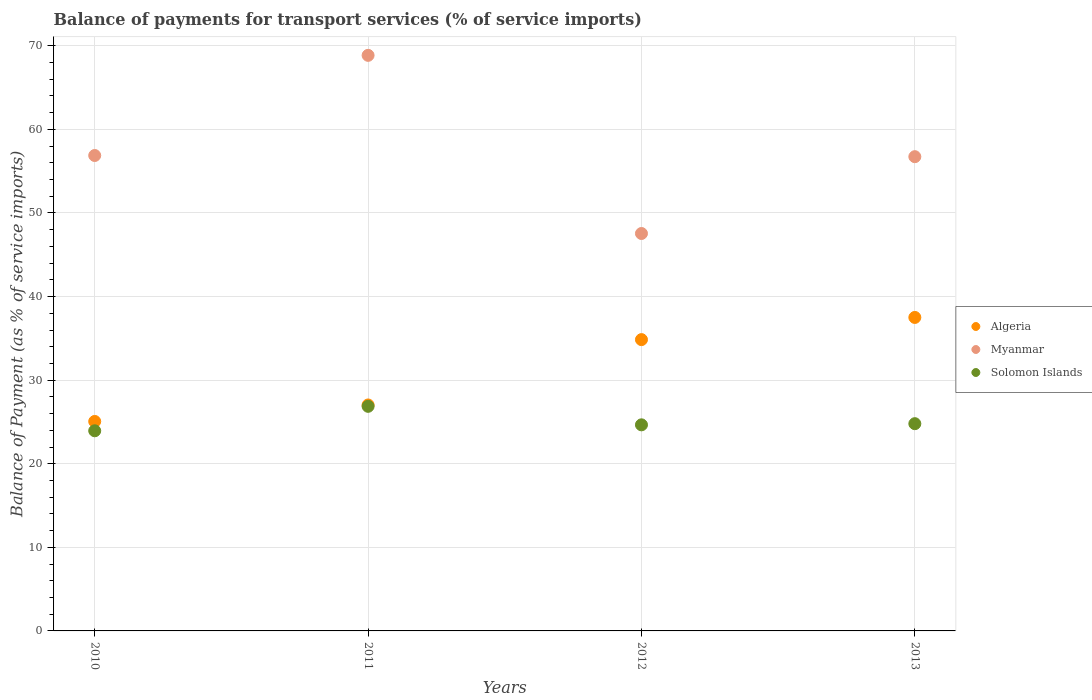How many different coloured dotlines are there?
Your answer should be compact. 3. Is the number of dotlines equal to the number of legend labels?
Make the answer very short. Yes. What is the balance of payments for transport services in Solomon Islands in 2011?
Keep it short and to the point. 26.87. Across all years, what is the maximum balance of payments for transport services in Algeria?
Your answer should be very brief. 37.5. Across all years, what is the minimum balance of payments for transport services in Solomon Islands?
Your answer should be compact. 23.94. In which year was the balance of payments for transport services in Algeria minimum?
Make the answer very short. 2010. What is the total balance of payments for transport services in Myanmar in the graph?
Offer a terse response. 230.02. What is the difference between the balance of payments for transport services in Myanmar in 2010 and that in 2013?
Give a very brief answer. 0.14. What is the difference between the balance of payments for transport services in Myanmar in 2011 and the balance of payments for transport services in Algeria in 2010?
Your answer should be very brief. 43.8. What is the average balance of payments for transport services in Solomon Islands per year?
Your answer should be compact. 25.07. In the year 2011, what is the difference between the balance of payments for transport services in Myanmar and balance of payments for transport services in Algeria?
Your answer should be compact. 41.83. In how many years, is the balance of payments for transport services in Solomon Islands greater than 38 %?
Give a very brief answer. 0. What is the ratio of the balance of payments for transport services in Myanmar in 2010 to that in 2011?
Offer a very short reply. 0.83. Is the difference between the balance of payments for transport services in Myanmar in 2012 and 2013 greater than the difference between the balance of payments for transport services in Algeria in 2012 and 2013?
Provide a short and direct response. No. What is the difference between the highest and the second highest balance of payments for transport services in Solomon Islands?
Provide a succinct answer. 2.08. What is the difference between the highest and the lowest balance of payments for transport services in Myanmar?
Make the answer very short. 21.31. Does the balance of payments for transport services in Solomon Islands monotonically increase over the years?
Your answer should be very brief. No. What is the difference between two consecutive major ticks on the Y-axis?
Give a very brief answer. 10. Does the graph contain grids?
Give a very brief answer. Yes. Where does the legend appear in the graph?
Provide a short and direct response. Center right. How many legend labels are there?
Give a very brief answer. 3. How are the legend labels stacked?
Give a very brief answer. Vertical. What is the title of the graph?
Your response must be concise. Balance of payments for transport services (% of service imports). Does "Samoa" appear as one of the legend labels in the graph?
Provide a short and direct response. No. What is the label or title of the X-axis?
Give a very brief answer. Years. What is the label or title of the Y-axis?
Offer a terse response. Balance of Payment (as % of service imports). What is the Balance of Payment (as % of service imports) of Algeria in 2010?
Provide a short and direct response. 25.06. What is the Balance of Payment (as % of service imports) in Myanmar in 2010?
Provide a short and direct response. 56.88. What is the Balance of Payment (as % of service imports) of Solomon Islands in 2010?
Provide a short and direct response. 23.94. What is the Balance of Payment (as % of service imports) of Algeria in 2011?
Your answer should be compact. 27.03. What is the Balance of Payment (as % of service imports) of Myanmar in 2011?
Offer a very short reply. 68.86. What is the Balance of Payment (as % of service imports) in Solomon Islands in 2011?
Give a very brief answer. 26.87. What is the Balance of Payment (as % of service imports) of Algeria in 2012?
Your answer should be compact. 34.85. What is the Balance of Payment (as % of service imports) in Myanmar in 2012?
Offer a terse response. 47.55. What is the Balance of Payment (as % of service imports) of Solomon Islands in 2012?
Offer a very short reply. 24.66. What is the Balance of Payment (as % of service imports) in Algeria in 2013?
Your answer should be very brief. 37.5. What is the Balance of Payment (as % of service imports) of Myanmar in 2013?
Your answer should be compact. 56.74. What is the Balance of Payment (as % of service imports) of Solomon Islands in 2013?
Offer a very short reply. 24.79. Across all years, what is the maximum Balance of Payment (as % of service imports) in Algeria?
Ensure brevity in your answer.  37.5. Across all years, what is the maximum Balance of Payment (as % of service imports) in Myanmar?
Ensure brevity in your answer.  68.86. Across all years, what is the maximum Balance of Payment (as % of service imports) of Solomon Islands?
Make the answer very short. 26.87. Across all years, what is the minimum Balance of Payment (as % of service imports) of Algeria?
Your answer should be very brief. 25.06. Across all years, what is the minimum Balance of Payment (as % of service imports) of Myanmar?
Provide a succinct answer. 47.55. Across all years, what is the minimum Balance of Payment (as % of service imports) in Solomon Islands?
Provide a short and direct response. 23.94. What is the total Balance of Payment (as % of service imports) of Algeria in the graph?
Your answer should be very brief. 124.45. What is the total Balance of Payment (as % of service imports) of Myanmar in the graph?
Your answer should be very brief. 230.02. What is the total Balance of Payment (as % of service imports) in Solomon Islands in the graph?
Make the answer very short. 100.26. What is the difference between the Balance of Payment (as % of service imports) in Algeria in 2010 and that in 2011?
Your answer should be very brief. -1.97. What is the difference between the Balance of Payment (as % of service imports) of Myanmar in 2010 and that in 2011?
Your response must be concise. -11.98. What is the difference between the Balance of Payment (as % of service imports) of Solomon Islands in 2010 and that in 2011?
Offer a very short reply. -2.93. What is the difference between the Balance of Payment (as % of service imports) of Algeria in 2010 and that in 2012?
Keep it short and to the point. -9.79. What is the difference between the Balance of Payment (as % of service imports) in Myanmar in 2010 and that in 2012?
Give a very brief answer. 9.33. What is the difference between the Balance of Payment (as % of service imports) in Solomon Islands in 2010 and that in 2012?
Keep it short and to the point. -0.71. What is the difference between the Balance of Payment (as % of service imports) of Algeria in 2010 and that in 2013?
Make the answer very short. -12.44. What is the difference between the Balance of Payment (as % of service imports) of Myanmar in 2010 and that in 2013?
Give a very brief answer. 0.14. What is the difference between the Balance of Payment (as % of service imports) in Solomon Islands in 2010 and that in 2013?
Provide a succinct answer. -0.85. What is the difference between the Balance of Payment (as % of service imports) of Algeria in 2011 and that in 2012?
Provide a short and direct response. -7.82. What is the difference between the Balance of Payment (as % of service imports) in Myanmar in 2011 and that in 2012?
Offer a terse response. 21.31. What is the difference between the Balance of Payment (as % of service imports) of Solomon Islands in 2011 and that in 2012?
Offer a very short reply. 2.21. What is the difference between the Balance of Payment (as % of service imports) in Algeria in 2011 and that in 2013?
Provide a short and direct response. -10.47. What is the difference between the Balance of Payment (as % of service imports) in Myanmar in 2011 and that in 2013?
Your answer should be compact. 12.12. What is the difference between the Balance of Payment (as % of service imports) of Solomon Islands in 2011 and that in 2013?
Offer a very short reply. 2.08. What is the difference between the Balance of Payment (as % of service imports) of Algeria in 2012 and that in 2013?
Give a very brief answer. -2.65. What is the difference between the Balance of Payment (as % of service imports) of Myanmar in 2012 and that in 2013?
Your answer should be compact. -9.19. What is the difference between the Balance of Payment (as % of service imports) in Solomon Islands in 2012 and that in 2013?
Your response must be concise. -0.14. What is the difference between the Balance of Payment (as % of service imports) in Algeria in 2010 and the Balance of Payment (as % of service imports) in Myanmar in 2011?
Your response must be concise. -43.8. What is the difference between the Balance of Payment (as % of service imports) in Algeria in 2010 and the Balance of Payment (as % of service imports) in Solomon Islands in 2011?
Provide a short and direct response. -1.81. What is the difference between the Balance of Payment (as % of service imports) of Myanmar in 2010 and the Balance of Payment (as % of service imports) of Solomon Islands in 2011?
Your response must be concise. 30.01. What is the difference between the Balance of Payment (as % of service imports) of Algeria in 2010 and the Balance of Payment (as % of service imports) of Myanmar in 2012?
Offer a terse response. -22.48. What is the difference between the Balance of Payment (as % of service imports) in Algeria in 2010 and the Balance of Payment (as % of service imports) in Solomon Islands in 2012?
Offer a very short reply. 0.41. What is the difference between the Balance of Payment (as % of service imports) of Myanmar in 2010 and the Balance of Payment (as % of service imports) of Solomon Islands in 2012?
Provide a short and direct response. 32.22. What is the difference between the Balance of Payment (as % of service imports) of Algeria in 2010 and the Balance of Payment (as % of service imports) of Myanmar in 2013?
Provide a short and direct response. -31.67. What is the difference between the Balance of Payment (as % of service imports) of Algeria in 2010 and the Balance of Payment (as % of service imports) of Solomon Islands in 2013?
Keep it short and to the point. 0.27. What is the difference between the Balance of Payment (as % of service imports) in Myanmar in 2010 and the Balance of Payment (as % of service imports) in Solomon Islands in 2013?
Your answer should be very brief. 32.08. What is the difference between the Balance of Payment (as % of service imports) in Algeria in 2011 and the Balance of Payment (as % of service imports) in Myanmar in 2012?
Your response must be concise. -20.51. What is the difference between the Balance of Payment (as % of service imports) in Algeria in 2011 and the Balance of Payment (as % of service imports) in Solomon Islands in 2012?
Provide a short and direct response. 2.38. What is the difference between the Balance of Payment (as % of service imports) of Myanmar in 2011 and the Balance of Payment (as % of service imports) of Solomon Islands in 2012?
Offer a very short reply. 44.2. What is the difference between the Balance of Payment (as % of service imports) of Algeria in 2011 and the Balance of Payment (as % of service imports) of Myanmar in 2013?
Keep it short and to the point. -29.7. What is the difference between the Balance of Payment (as % of service imports) in Algeria in 2011 and the Balance of Payment (as % of service imports) in Solomon Islands in 2013?
Offer a very short reply. 2.24. What is the difference between the Balance of Payment (as % of service imports) in Myanmar in 2011 and the Balance of Payment (as % of service imports) in Solomon Islands in 2013?
Provide a short and direct response. 44.07. What is the difference between the Balance of Payment (as % of service imports) in Algeria in 2012 and the Balance of Payment (as % of service imports) in Myanmar in 2013?
Provide a succinct answer. -21.89. What is the difference between the Balance of Payment (as % of service imports) of Algeria in 2012 and the Balance of Payment (as % of service imports) of Solomon Islands in 2013?
Give a very brief answer. 10.06. What is the difference between the Balance of Payment (as % of service imports) of Myanmar in 2012 and the Balance of Payment (as % of service imports) of Solomon Islands in 2013?
Offer a very short reply. 22.75. What is the average Balance of Payment (as % of service imports) of Algeria per year?
Give a very brief answer. 31.11. What is the average Balance of Payment (as % of service imports) in Myanmar per year?
Offer a very short reply. 57.5. What is the average Balance of Payment (as % of service imports) in Solomon Islands per year?
Offer a very short reply. 25.07. In the year 2010, what is the difference between the Balance of Payment (as % of service imports) in Algeria and Balance of Payment (as % of service imports) in Myanmar?
Your response must be concise. -31.82. In the year 2010, what is the difference between the Balance of Payment (as % of service imports) in Algeria and Balance of Payment (as % of service imports) in Solomon Islands?
Give a very brief answer. 1.12. In the year 2010, what is the difference between the Balance of Payment (as % of service imports) in Myanmar and Balance of Payment (as % of service imports) in Solomon Islands?
Offer a terse response. 32.93. In the year 2011, what is the difference between the Balance of Payment (as % of service imports) of Algeria and Balance of Payment (as % of service imports) of Myanmar?
Offer a very short reply. -41.83. In the year 2011, what is the difference between the Balance of Payment (as % of service imports) in Algeria and Balance of Payment (as % of service imports) in Solomon Islands?
Provide a short and direct response. 0.16. In the year 2011, what is the difference between the Balance of Payment (as % of service imports) in Myanmar and Balance of Payment (as % of service imports) in Solomon Islands?
Give a very brief answer. 41.99. In the year 2012, what is the difference between the Balance of Payment (as % of service imports) in Algeria and Balance of Payment (as % of service imports) in Myanmar?
Provide a succinct answer. -12.7. In the year 2012, what is the difference between the Balance of Payment (as % of service imports) of Algeria and Balance of Payment (as % of service imports) of Solomon Islands?
Provide a short and direct response. 10.19. In the year 2012, what is the difference between the Balance of Payment (as % of service imports) in Myanmar and Balance of Payment (as % of service imports) in Solomon Islands?
Keep it short and to the point. 22.89. In the year 2013, what is the difference between the Balance of Payment (as % of service imports) in Algeria and Balance of Payment (as % of service imports) in Myanmar?
Provide a short and direct response. -19.23. In the year 2013, what is the difference between the Balance of Payment (as % of service imports) in Algeria and Balance of Payment (as % of service imports) in Solomon Islands?
Make the answer very short. 12.71. In the year 2013, what is the difference between the Balance of Payment (as % of service imports) in Myanmar and Balance of Payment (as % of service imports) in Solomon Islands?
Give a very brief answer. 31.94. What is the ratio of the Balance of Payment (as % of service imports) of Algeria in 2010 to that in 2011?
Offer a terse response. 0.93. What is the ratio of the Balance of Payment (as % of service imports) in Myanmar in 2010 to that in 2011?
Provide a succinct answer. 0.83. What is the ratio of the Balance of Payment (as % of service imports) of Solomon Islands in 2010 to that in 2011?
Offer a terse response. 0.89. What is the ratio of the Balance of Payment (as % of service imports) in Algeria in 2010 to that in 2012?
Provide a succinct answer. 0.72. What is the ratio of the Balance of Payment (as % of service imports) of Myanmar in 2010 to that in 2012?
Make the answer very short. 1.2. What is the ratio of the Balance of Payment (as % of service imports) in Solomon Islands in 2010 to that in 2012?
Provide a short and direct response. 0.97. What is the ratio of the Balance of Payment (as % of service imports) in Algeria in 2010 to that in 2013?
Give a very brief answer. 0.67. What is the ratio of the Balance of Payment (as % of service imports) in Myanmar in 2010 to that in 2013?
Provide a succinct answer. 1. What is the ratio of the Balance of Payment (as % of service imports) in Solomon Islands in 2010 to that in 2013?
Provide a short and direct response. 0.97. What is the ratio of the Balance of Payment (as % of service imports) of Algeria in 2011 to that in 2012?
Your answer should be compact. 0.78. What is the ratio of the Balance of Payment (as % of service imports) in Myanmar in 2011 to that in 2012?
Offer a very short reply. 1.45. What is the ratio of the Balance of Payment (as % of service imports) of Solomon Islands in 2011 to that in 2012?
Give a very brief answer. 1.09. What is the ratio of the Balance of Payment (as % of service imports) in Algeria in 2011 to that in 2013?
Offer a terse response. 0.72. What is the ratio of the Balance of Payment (as % of service imports) in Myanmar in 2011 to that in 2013?
Give a very brief answer. 1.21. What is the ratio of the Balance of Payment (as % of service imports) in Solomon Islands in 2011 to that in 2013?
Provide a succinct answer. 1.08. What is the ratio of the Balance of Payment (as % of service imports) in Algeria in 2012 to that in 2013?
Your answer should be compact. 0.93. What is the ratio of the Balance of Payment (as % of service imports) in Myanmar in 2012 to that in 2013?
Your answer should be compact. 0.84. What is the difference between the highest and the second highest Balance of Payment (as % of service imports) of Algeria?
Provide a short and direct response. 2.65. What is the difference between the highest and the second highest Balance of Payment (as % of service imports) of Myanmar?
Provide a succinct answer. 11.98. What is the difference between the highest and the second highest Balance of Payment (as % of service imports) in Solomon Islands?
Ensure brevity in your answer.  2.08. What is the difference between the highest and the lowest Balance of Payment (as % of service imports) in Algeria?
Offer a very short reply. 12.44. What is the difference between the highest and the lowest Balance of Payment (as % of service imports) of Myanmar?
Ensure brevity in your answer.  21.31. What is the difference between the highest and the lowest Balance of Payment (as % of service imports) in Solomon Islands?
Provide a succinct answer. 2.93. 